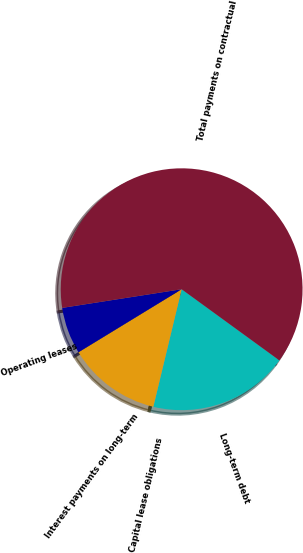<chart> <loc_0><loc_0><loc_500><loc_500><pie_chart><fcel>Long-term debt<fcel>Capital lease obligations<fcel>Interest payments on long-term<fcel>Operating leases<fcel>Total payments on contractual<nl><fcel>18.75%<fcel>0.01%<fcel>12.5%<fcel>6.26%<fcel>62.47%<nl></chart> 